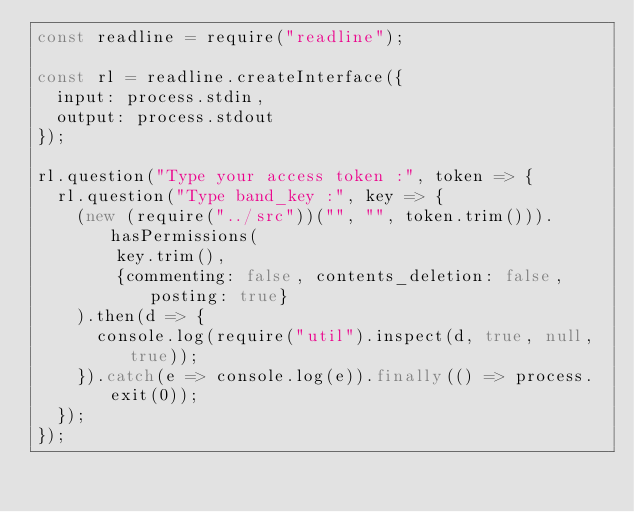Convert code to text. <code><loc_0><loc_0><loc_500><loc_500><_JavaScript_>const readline = require("readline");

const rl = readline.createInterface({
	input: process.stdin,
	output: process.stdout
});

rl.question("Type your access token :", token => {
	rl.question("Type band_key :", key => {
		(new (require("../src"))("", "", token.trim())).hasPermissions(
				key.trim(),
				{commenting: false, contents_deletion: false, posting: true}
		).then(d => {
			console.log(require("util").inspect(d, true, null, true));
		}).catch(e => console.log(e)).finally(() => process.exit(0));
	});
});</code> 